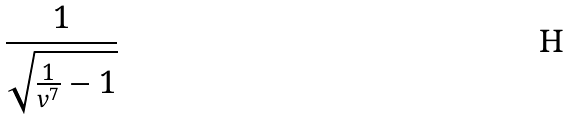Convert formula to latex. <formula><loc_0><loc_0><loc_500><loc_500>\frac { 1 } { \sqrt { \frac { 1 } { v ^ { 7 } } - 1 } }</formula> 